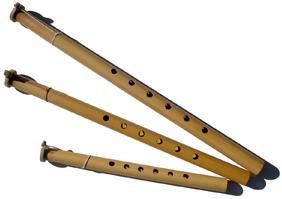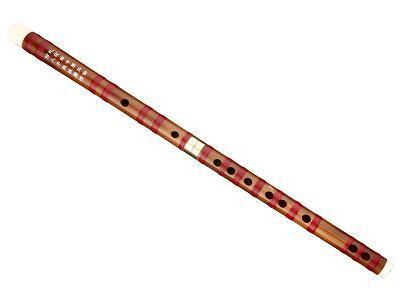The first image is the image on the left, the second image is the image on the right. Analyze the images presented: Is the assertion "A red tassel is connected to a straight flute." valid? Answer yes or no. No. The first image is the image on the left, the second image is the image on the right. Given the left and right images, does the statement "One image shows a diagonally displayed, perforated stick-shaped instrument with a red tassel at its lower end, and the other image shows a similar gold and black instrument with no tassel." hold true? Answer yes or no. No. 